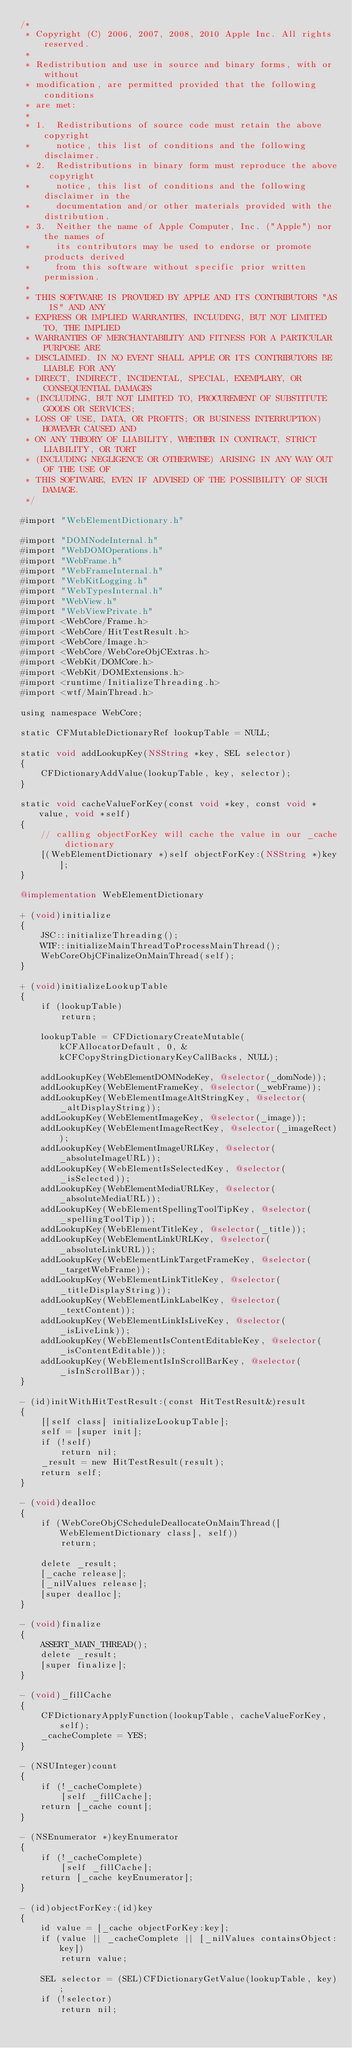<code> <loc_0><loc_0><loc_500><loc_500><_ObjectiveC_>/*
 * Copyright (C) 2006, 2007, 2008, 2010 Apple Inc. All rights reserved.
 *
 * Redistribution and use in source and binary forms, with or without
 * modification, are permitted provided that the following conditions
 * are met:
 *
 * 1.  Redistributions of source code must retain the above copyright
 *     notice, this list of conditions and the following disclaimer. 
 * 2.  Redistributions in binary form must reproduce the above copyright
 *     notice, this list of conditions and the following disclaimer in the
 *     documentation and/or other materials provided with the distribution. 
 * 3.  Neither the name of Apple Computer, Inc. ("Apple") nor the names of
 *     its contributors may be used to endorse or promote products derived
 *     from this software without specific prior written permission. 
 *
 * THIS SOFTWARE IS PROVIDED BY APPLE AND ITS CONTRIBUTORS "AS IS" AND ANY
 * EXPRESS OR IMPLIED WARRANTIES, INCLUDING, BUT NOT LIMITED TO, THE IMPLIED
 * WARRANTIES OF MERCHANTABILITY AND FITNESS FOR A PARTICULAR PURPOSE ARE
 * DISCLAIMED. IN NO EVENT SHALL APPLE OR ITS CONTRIBUTORS BE LIABLE FOR ANY
 * DIRECT, INDIRECT, INCIDENTAL, SPECIAL, EXEMPLARY, OR CONSEQUENTIAL DAMAGES
 * (INCLUDING, BUT NOT LIMITED TO, PROCUREMENT OF SUBSTITUTE GOODS OR SERVICES;
 * LOSS OF USE, DATA, OR PROFITS; OR BUSINESS INTERRUPTION) HOWEVER CAUSED AND
 * ON ANY THEORY OF LIABILITY, WHETHER IN CONTRACT, STRICT LIABILITY, OR TORT
 * (INCLUDING NEGLIGENCE OR OTHERWISE) ARISING IN ANY WAY OUT OF THE USE OF
 * THIS SOFTWARE, EVEN IF ADVISED OF THE POSSIBILITY OF SUCH DAMAGE.
 */

#import "WebElementDictionary.h"

#import "DOMNodeInternal.h"
#import "WebDOMOperations.h"
#import "WebFrame.h"
#import "WebFrameInternal.h"
#import "WebKitLogging.h"
#import "WebTypesInternal.h"
#import "WebView.h"
#import "WebViewPrivate.h"
#import <WebCore/Frame.h>
#import <WebCore/HitTestResult.h>
#import <WebCore/Image.h>
#import <WebCore/WebCoreObjCExtras.h>
#import <WebKit/DOMCore.h>
#import <WebKit/DOMExtensions.h>
#import <runtime/InitializeThreading.h>
#import <wtf/MainThread.h>

using namespace WebCore;

static CFMutableDictionaryRef lookupTable = NULL;

static void addLookupKey(NSString *key, SEL selector)
{
    CFDictionaryAddValue(lookupTable, key, selector);
}

static void cacheValueForKey(const void *key, const void *value, void *self)
{
    // calling objectForKey will cache the value in our _cache dictionary
    [(WebElementDictionary *)self objectForKey:(NSString *)key];
}

@implementation WebElementDictionary

+ (void)initialize
{
    JSC::initializeThreading();
    WTF::initializeMainThreadToProcessMainThread();
    WebCoreObjCFinalizeOnMainThread(self);
}

+ (void)initializeLookupTable
{
    if (lookupTable)
        return;

    lookupTable = CFDictionaryCreateMutable(kCFAllocatorDefault, 0, &kCFCopyStringDictionaryKeyCallBacks, NULL);

    addLookupKey(WebElementDOMNodeKey, @selector(_domNode));
    addLookupKey(WebElementFrameKey, @selector(_webFrame));
    addLookupKey(WebElementImageAltStringKey, @selector(_altDisplayString));
    addLookupKey(WebElementImageKey, @selector(_image));
    addLookupKey(WebElementImageRectKey, @selector(_imageRect));
    addLookupKey(WebElementImageURLKey, @selector(_absoluteImageURL));
    addLookupKey(WebElementIsSelectedKey, @selector(_isSelected));
    addLookupKey(WebElementMediaURLKey, @selector(_absoluteMediaURL));
    addLookupKey(WebElementSpellingToolTipKey, @selector(_spellingToolTip));
    addLookupKey(WebElementTitleKey, @selector(_title));
    addLookupKey(WebElementLinkURLKey, @selector(_absoluteLinkURL));
    addLookupKey(WebElementLinkTargetFrameKey, @selector(_targetWebFrame));
    addLookupKey(WebElementLinkTitleKey, @selector(_titleDisplayString));
    addLookupKey(WebElementLinkLabelKey, @selector(_textContent));
    addLookupKey(WebElementLinkIsLiveKey, @selector(_isLiveLink));
    addLookupKey(WebElementIsContentEditableKey, @selector(_isContentEditable));
    addLookupKey(WebElementIsInScrollBarKey, @selector(_isInScrollBar));
}

- (id)initWithHitTestResult:(const HitTestResult&)result
{
    [[self class] initializeLookupTable];
    self = [super init];
    if (!self)
        return nil;
    _result = new HitTestResult(result);
    return self;
}

- (void)dealloc
{
    if (WebCoreObjCScheduleDeallocateOnMainThread([WebElementDictionary class], self))
        return;

    delete _result;
    [_cache release];
    [_nilValues release];
    [super dealloc];
}

- (void)finalize
{
    ASSERT_MAIN_THREAD();
    delete _result;
    [super finalize];
}

- (void)_fillCache
{
    CFDictionaryApplyFunction(lookupTable, cacheValueForKey, self);
    _cacheComplete = YES;
}

- (NSUInteger)count
{
    if (!_cacheComplete)
        [self _fillCache];
    return [_cache count];
}

- (NSEnumerator *)keyEnumerator
{
    if (!_cacheComplete)
        [self _fillCache];
    return [_cache keyEnumerator];
}

- (id)objectForKey:(id)key
{
    id value = [_cache objectForKey:key];
    if (value || _cacheComplete || [_nilValues containsObject:key])
        return value;

    SEL selector = (SEL)CFDictionaryGetValue(lookupTable, key);
    if (!selector)
        return nil;</code> 